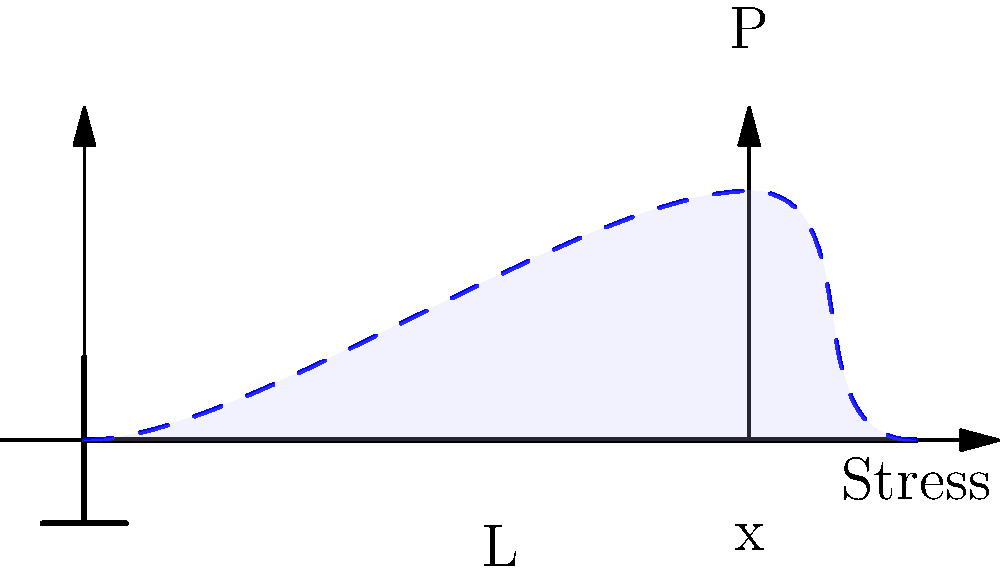In a cantilever beam subjected to a point load P at a distance x from the fixed end, how does the bending stress distribution change along the length of the beam? Consider this in the context of optimizing structural design for a sleek, minimalist product, similar to the approach Steve Jobs might have taken in Apple's product development. To understand the bending stress distribution in a cantilever beam, let's follow these steps:

1. Beam configuration:
   - The beam is fixed at one end and free at the other.
   - A point load P is applied at distance x from the fixed end.
   - Total length of the beam is L.

2. Bending moment equation:
   The bending moment M at any point along the beam is given by:
   $$M = P(L-x)$$
   where x is the distance from the fixed end.

3. Stress-moment relationship:
   The bending stress σ at any point is related to the bending moment by:
   $$σ = \frac{My}{I}$$
   where y is the distance from the neutral axis, and I is the moment of inertia.

4. Stress distribution:
   - At the fixed end (x = 0), the bending moment and stress are maximum.
   - The stress decreases linearly along the length of the beam.
   - At the point of load application (x = x), there's a sudden change in the stress gradient.
   - Beyond the point load, the stress continues to decrease linearly to zero at the free end.

5. Optimization perspective:
   - This stress distribution allows for material optimization, similar to how Jobs might have approached product design.
   - More material can be used at the fixed end where stress is highest.
   - The beam can be tapered towards the free end, reducing weight without compromising strength.

6. Innovative design approach:
   - Understanding this stress distribution enables designs that are both structurally sound and aesthetically pleasing.
   - It allows for the creation of sleek, minimalist structures that efficiently use materials.

This analysis demonstrates how engineering principles can be applied to create elegant, efficient designs, much like the philosophy behind Apple's product development under Steve Jobs' leadership.
Answer: The bending stress is maximum at the fixed end and decreases linearly along the beam's length, with a change in gradient at the point of load application. 